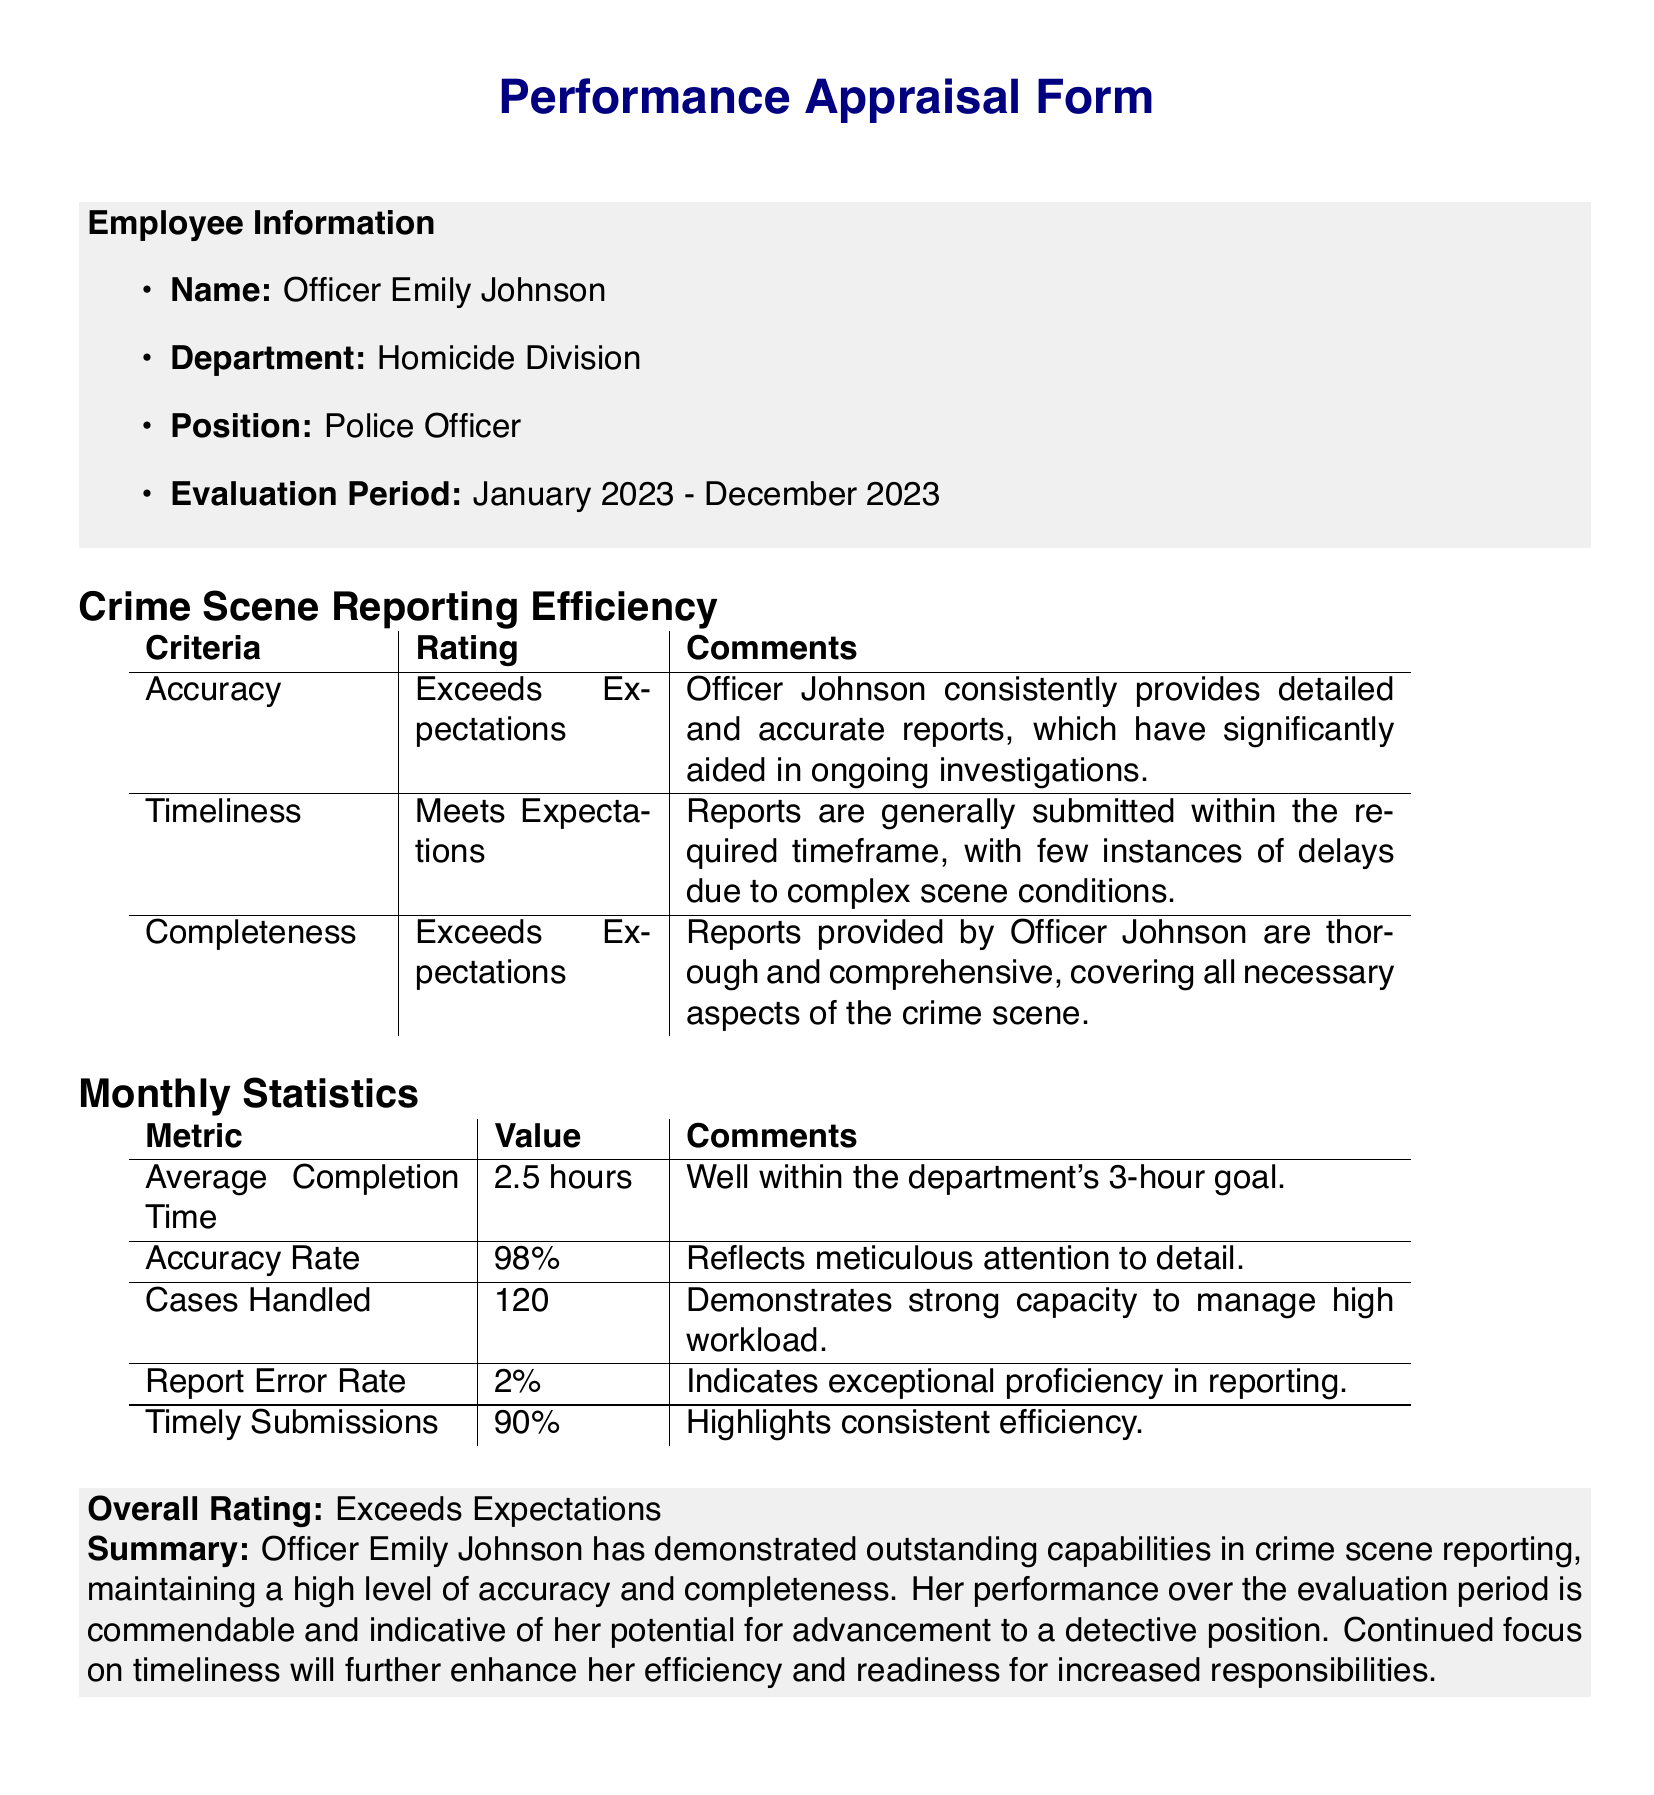What is the employee's name? The employee's name is explicitly stated in the document.
Answer: Officer Emily Johnson What is the evaluation period? The document specifies the time frame for the performance evaluation.
Answer: January 2023 - December 2023 What is the accuracy rating? The accuracy rating is provided in the performance appraisal section of the document.
Answer: Exceeds Expectations How many cases were handled? The number of cases handled is included in the monthly statistics table.
Answer: 120 What is the average completion time? The average completion time is mentioned under the monthly statistics.
Answer: 2.5 hours What percentage reflects the accuracy rate? The document details the accuracy rate as a percentage.
Answer: 98% What does the overall rating state? The overall rating is summarized at the end of the performance appraisal.
Answer: Exceeds Expectations What is the report error rate? The report error rate is specified in the monthly statistics section.
Answer: 2% What is noted about Officer Johnson's potential? The summary section addresses Officer Johnson's potential for career advancement.
Answer: Potential for advancement to a detective position How consistent are her timely submissions? The document states a specific percentage related to timely submissions in the statistics.
Answer: 90% 